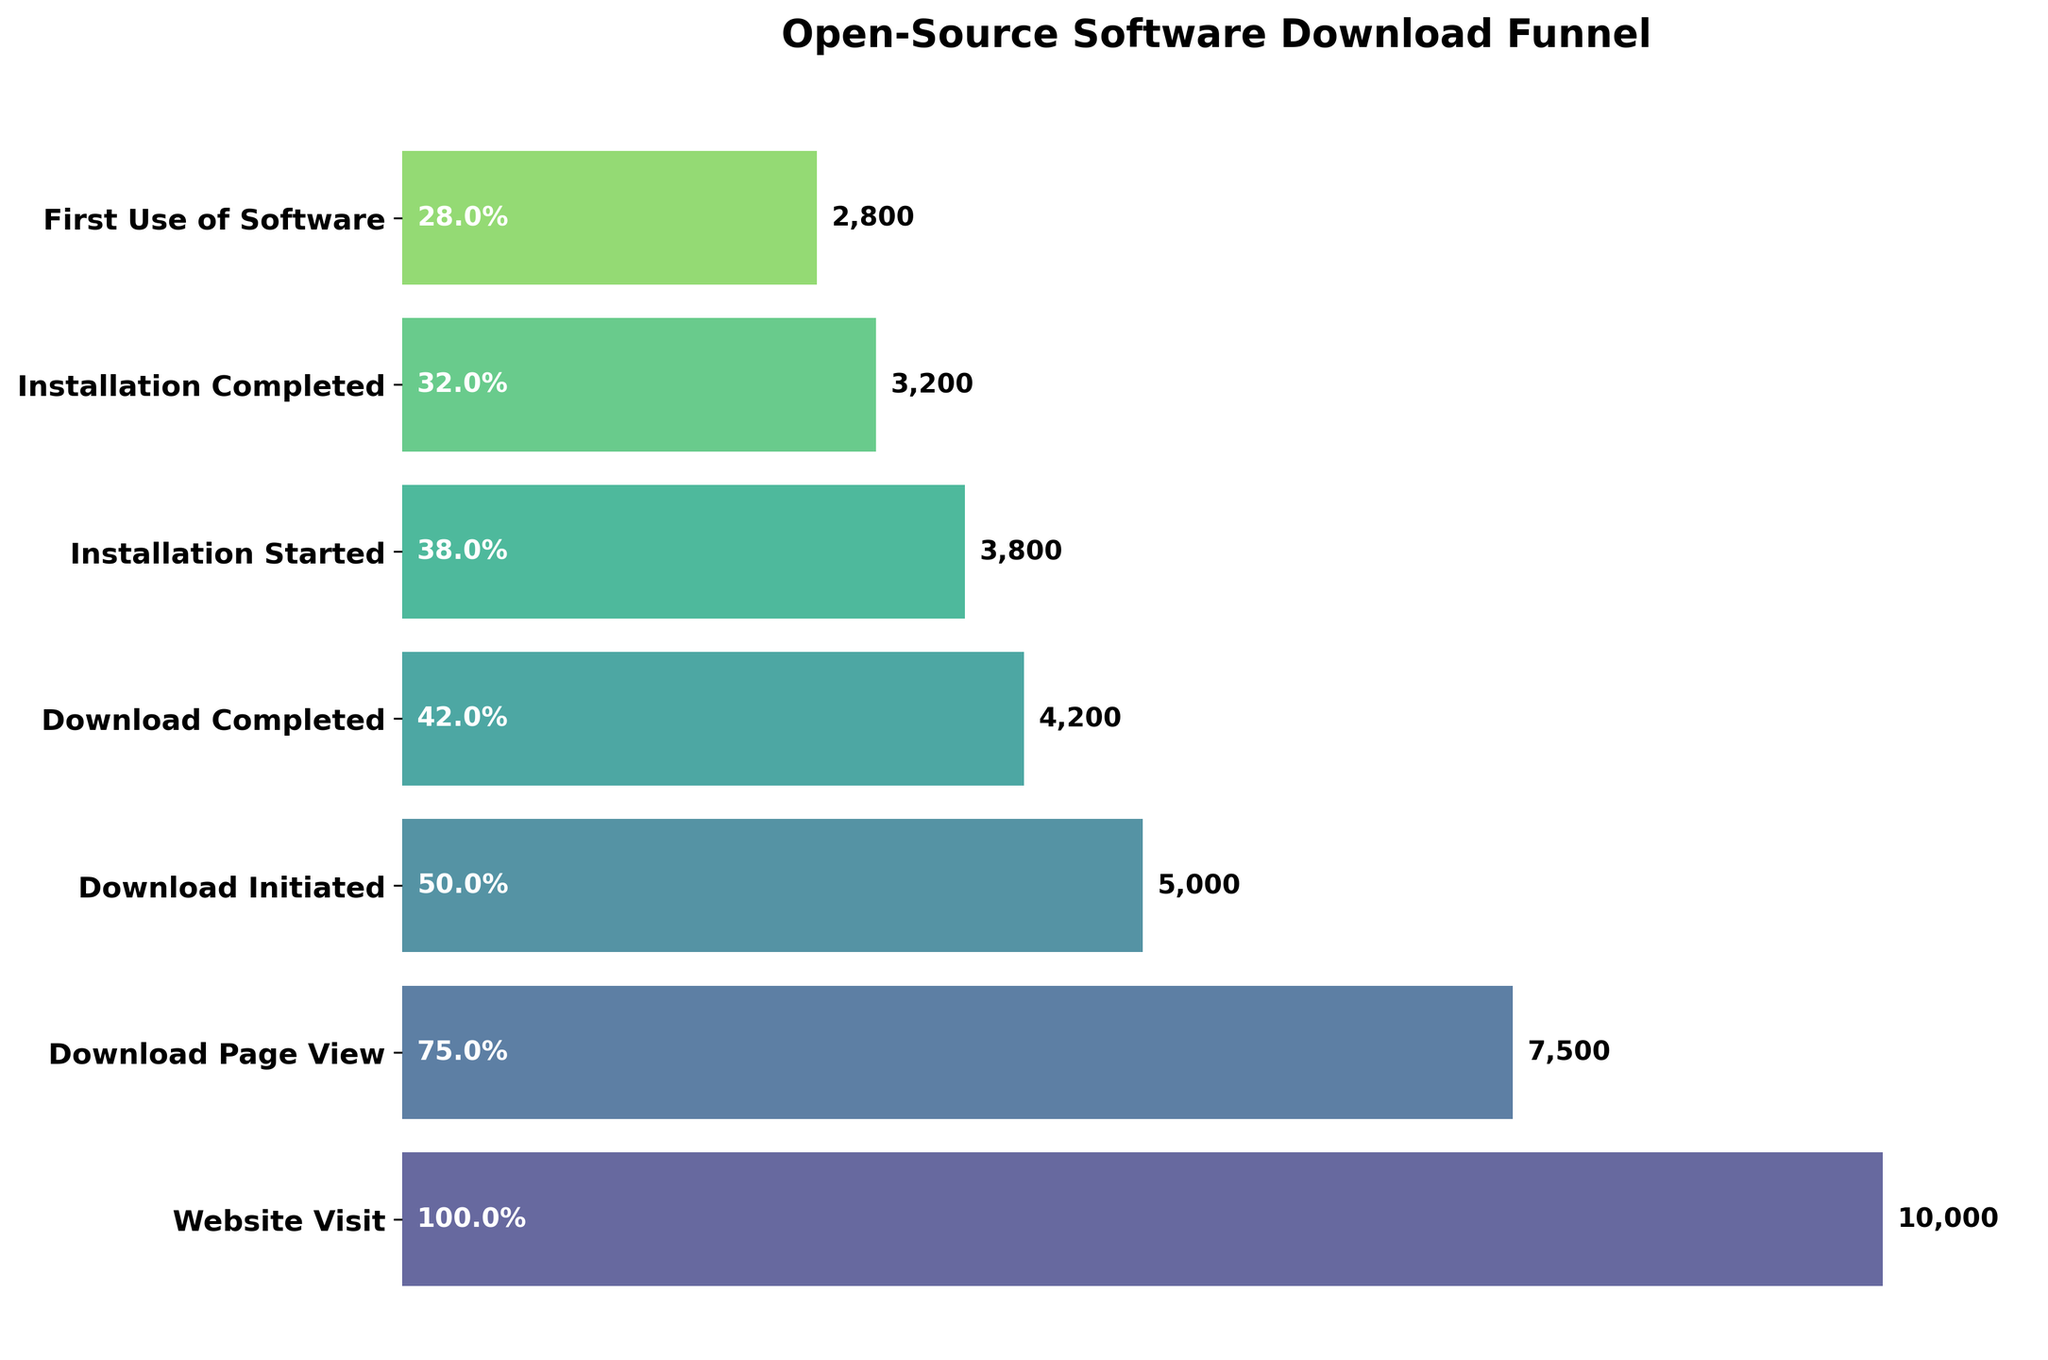How many stages are illustrated in the funnel chart? Count the stages listed on the y-axis.
Answer: 7 What is the title of the funnel chart? Read the text displayed at the top of the chart as the title.
Answer: Open-Source Software Download Funnel What percentage of users who visited the website started the download? Divide the number of users who initiated the download (5000) by the number of website visitors (10000) and multiply by 100. This is (5000/10000) * 100.
Answer: 50% By how many users does the number decrease from "Website Visit" to "Download Page View"? Subtract the number of users at "Download Page View" (7500) from those at "Website Visit" (10000). This is 10000 - 7500.
Answer: 2500 Which stage has the most significant drop in user numbers? Compare the differences in user numbers between each consecutive stage and identify the largest drop. The drop from "Download Initiated" (5000) to "Download Completed" (4200) is the largest at 800.
Answer: Download Initiated to Download Completed What is the percentage of users who completed the installation out of those who started it? Divide the number of users who completed the installation (3200) by the number of users who started it (3800) and multiply by 100. This is (3200/3800) * 100.
Answer: 84.2% Which stage has a percentage exactly halfway between 42% and 32% of the initial website visitors? Calculate the midpoint between 42% and 32%, which is 37%. Determine which stage has a user percentage close to 37%.
Answer: Installation Started How many users completed the download but did not start the installation? Subtract the number of users who started the installation (3800) from those who completed the download (4200). This is 4200 - 3800.
Answer: 400 What's the total user decrease from "Download Page View" to "First Use of Software"? Subtract the number of users at "First Use of Software" (2800) from those at "Download Page View" (7500). This is 7500 - 2800.
Answer: 4700 